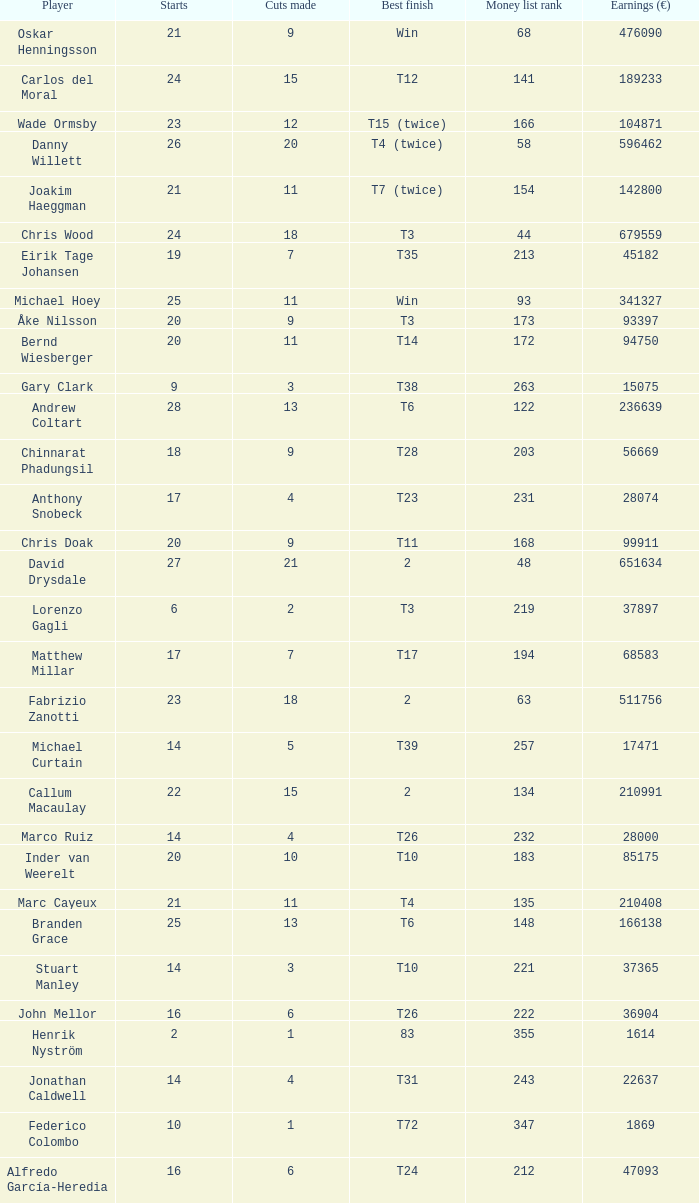How many earnings values are associated with players who had a best finish of T38? 1.0. 